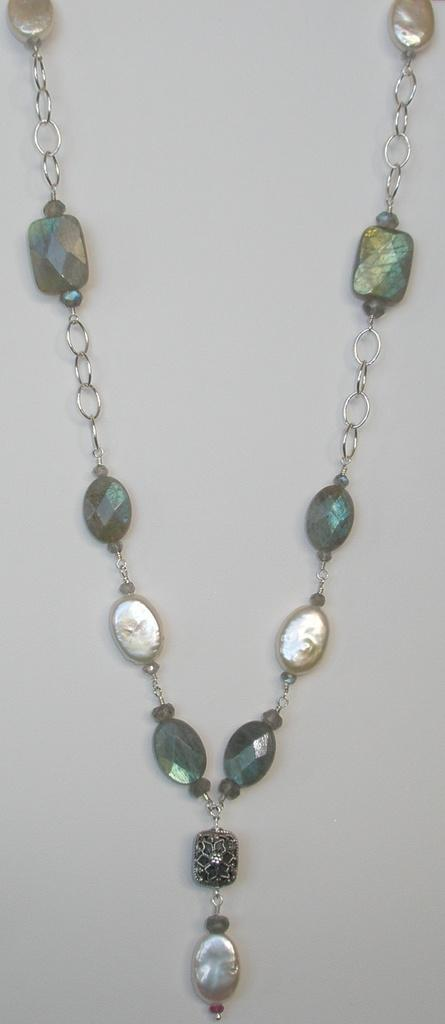What type of item can be seen in the image? There is jewelry in the image. How many clovers are present in the image? There are no clovers present in the image; it features jewelry. What type of dust can be seen on the jewelry in the image? There is no dust visible on the jewelry in the image. 